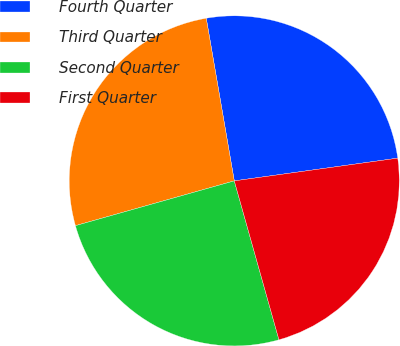<chart> <loc_0><loc_0><loc_500><loc_500><pie_chart><fcel>Fourth Quarter<fcel>Third Quarter<fcel>Second Quarter<fcel>First Quarter<nl><fcel>25.52%<fcel>26.66%<fcel>24.99%<fcel>22.84%<nl></chart> 